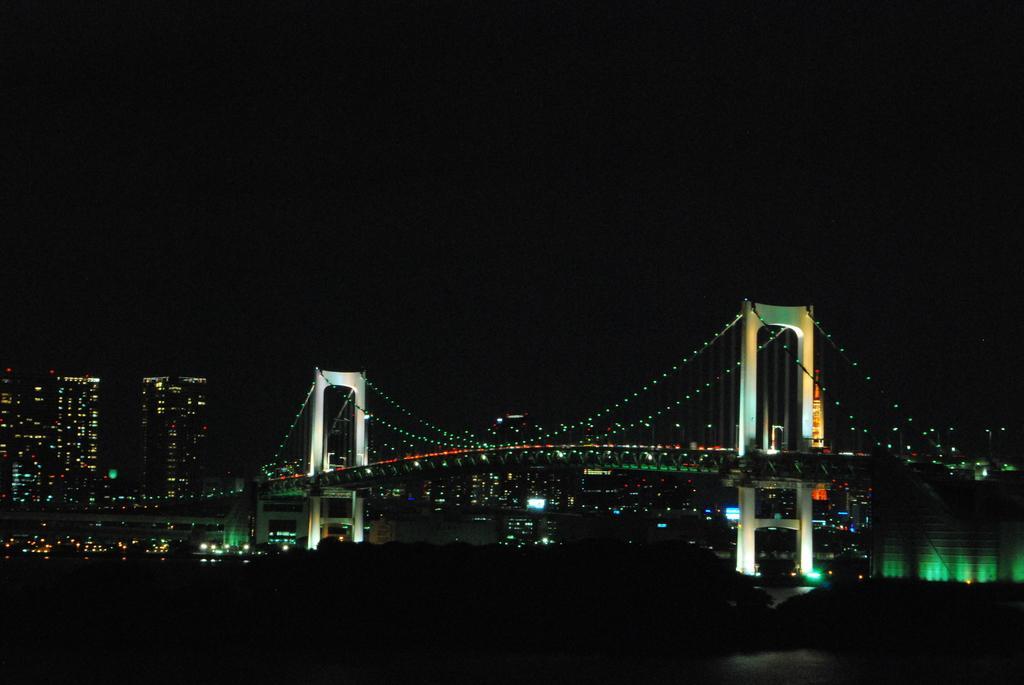Please provide a concise description of this image. In this image we can see a bridge with some lights. In the background, we can see a group of buildings and the sky. 